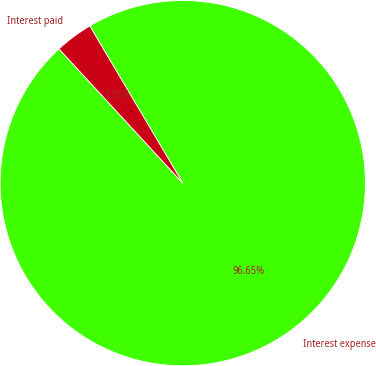Convert chart to OTSL. <chart><loc_0><loc_0><loc_500><loc_500><pie_chart><fcel>Interest expense<fcel>Interest paid<nl><fcel>96.65%<fcel>3.35%<nl></chart> 